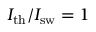Convert formula to latex. <formula><loc_0><loc_0><loc_500><loc_500>I _ { t h } / I _ { s w } = 1</formula> 